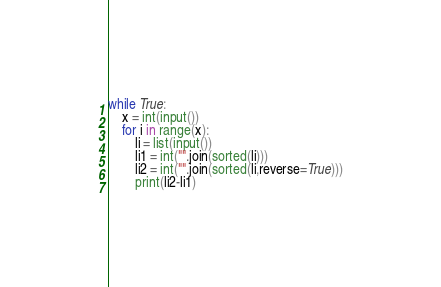<code> <loc_0><loc_0><loc_500><loc_500><_Python_>while True:
	x = int(input())
	for i in range(x):
		li = list(input())
		li1 = int("".join(sorted(li)))
		li2 = int("".join(sorted(li,reverse=True)))
		print(li2-li1)
</code> 